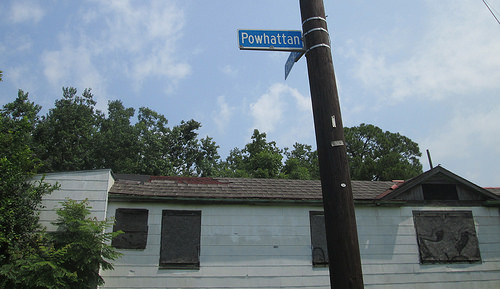<image>
Is the tree next to the pole? No. The tree is not positioned next to the pole. They are located in different areas of the scene. 